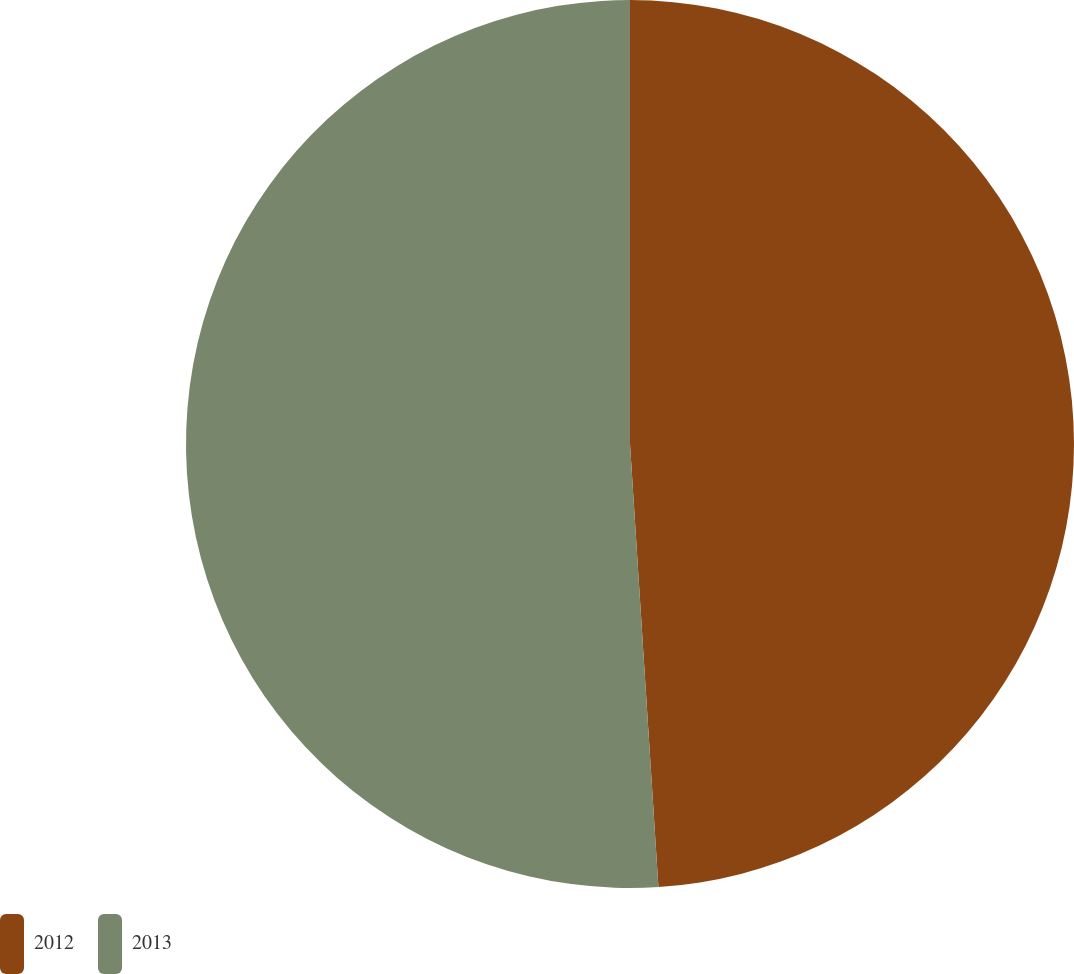Convert chart. <chart><loc_0><loc_0><loc_500><loc_500><pie_chart><fcel>2012<fcel>2013<nl><fcel>48.98%<fcel>51.02%<nl></chart> 